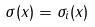<formula> <loc_0><loc_0><loc_500><loc_500>\sigma ( x ) = \sigma _ { i } ( x )</formula> 